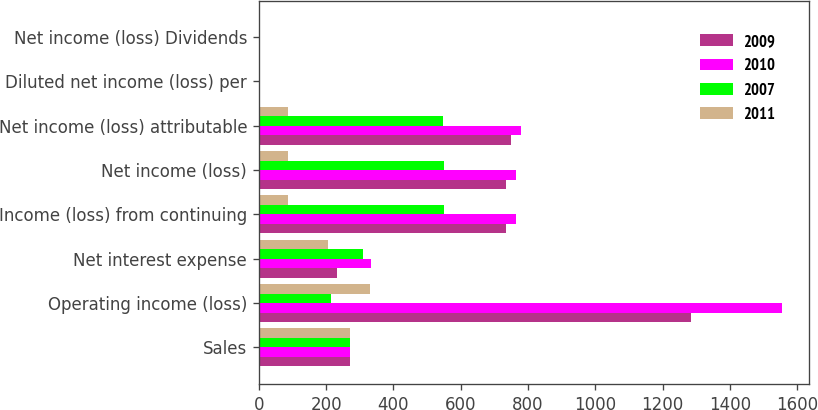<chart> <loc_0><loc_0><loc_500><loc_500><stacked_bar_chart><ecel><fcel>Sales<fcel>Operating income (loss)<fcel>Net interest expense<fcel>Income (loss) from continuing<fcel>Net income (loss)<fcel>Net income (loss) attributable<fcel>Diluted net income (loss) per<fcel>Net income (loss) Dividends<nl><fcel>2009<fcel>270.5<fcel>1285<fcel>231<fcel>733<fcel>733<fcel>750<fcel>1.97<fcel>1.97<nl><fcel>2010<fcel>270.5<fcel>1556<fcel>333<fcel>765<fcel>765<fcel>780<fcel>2.06<fcel>2.06<nl><fcel>2007<fcel>270.5<fcel>215<fcel>310<fcel>550<fcel>551<fcel>547<fcel>1.47<fcel>1.47<nl><fcel>2011<fcel>270.5<fcel>331<fcel>206<fcel>86<fcel>86<fcel>86<fcel>0.24<fcel>0.24<nl></chart> 